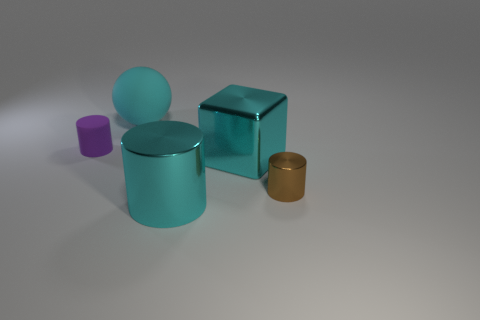Add 4 large cyan blocks. How many objects exist? 9 Subtract all cylinders. How many objects are left? 2 Subtract all small metal cylinders. Subtract all small brown shiny objects. How many objects are left? 3 Add 3 purple rubber objects. How many purple rubber objects are left? 4 Add 1 big blue things. How many big blue things exist? 1 Subtract 0 blue balls. How many objects are left? 5 